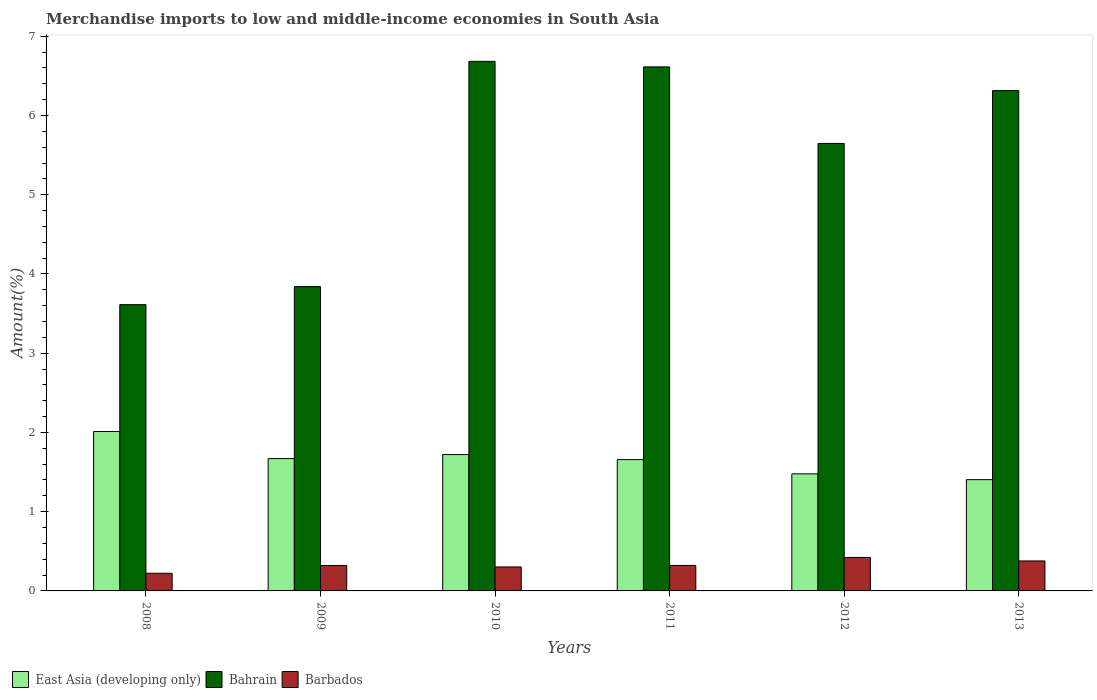How many groups of bars are there?
Your answer should be very brief. 6. Are the number of bars per tick equal to the number of legend labels?
Ensure brevity in your answer.  Yes. Are the number of bars on each tick of the X-axis equal?
Give a very brief answer. Yes. What is the label of the 1st group of bars from the left?
Ensure brevity in your answer.  2008. What is the percentage of amount earned from merchandise imports in East Asia (developing only) in 2012?
Give a very brief answer. 1.48. Across all years, what is the maximum percentage of amount earned from merchandise imports in Bahrain?
Give a very brief answer. 6.68. Across all years, what is the minimum percentage of amount earned from merchandise imports in Barbados?
Ensure brevity in your answer.  0.22. What is the total percentage of amount earned from merchandise imports in East Asia (developing only) in the graph?
Your answer should be compact. 9.94. What is the difference between the percentage of amount earned from merchandise imports in Barbados in 2008 and that in 2011?
Your answer should be compact. -0.1. What is the difference between the percentage of amount earned from merchandise imports in East Asia (developing only) in 2011 and the percentage of amount earned from merchandise imports in Bahrain in 2013?
Offer a terse response. -4.66. What is the average percentage of amount earned from merchandise imports in Bahrain per year?
Your answer should be compact. 5.45. In the year 2012, what is the difference between the percentage of amount earned from merchandise imports in Bahrain and percentage of amount earned from merchandise imports in East Asia (developing only)?
Keep it short and to the point. 4.17. In how many years, is the percentage of amount earned from merchandise imports in Barbados greater than 2.2 %?
Offer a terse response. 0. What is the ratio of the percentage of amount earned from merchandise imports in Bahrain in 2010 to that in 2012?
Provide a succinct answer. 1.18. Is the difference between the percentage of amount earned from merchandise imports in Bahrain in 2010 and 2011 greater than the difference between the percentage of amount earned from merchandise imports in East Asia (developing only) in 2010 and 2011?
Offer a very short reply. Yes. What is the difference between the highest and the second highest percentage of amount earned from merchandise imports in Barbados?
Your answer should be very brief. 0.04. What is the difference between the highest and the lowest percentage of amount earned from merchandise imports in Barbados?
Offer a very short reply. 0.2. What does the 3rd bar from the left in 2013 represents?
Your answer should be very brief. Barbados. What does the 2nd bar from the right in 2009 represents?
Offer a very short reply. Bahrain. Are all the bars in the graph horizontal?
Your response must be concise. No. Are the values on the major ticks of Y-axis written in scientific E-notation?
Ensure brevity in your answer.  No. Where does the legend appear in the graph?
Provide a succinct answer. Bottom left. What is the title of the graph?
Your answer should be very brief. Merchandise imports to low and middle-income economies in South Asia. What is the label or title of the Y-axis?
Make the answer very short. Amount(%). What is the Amount(%) in East Asia (developing only) in 2008?
Provide a succinct answer. 2.01. What is the Amount(%) of Bahrain in 2008?
Your response must be concise. 3.61. What is the Amount(%) of Barbados in 2008?
Keep it short and to the point. 0.22. What is the Amount(%) in East Asia (developing only) in 2009?
Give a very brief answer. 1.67. What is the Amount(%) of Bahrain in 2009?
Offer a very short reply. 3.84. What is the Amount(%) of Barbados in 2009?
Offer a very short reply. 0.32. What is the Amount(%) in East Asia (developing only) in 2010?
Offer a very short reply. 1.72. What is the Amount(%) of Bahrain in 2010?
Make the answer very short. 6.68. What is the Amount(%) of Barbados in 2010?
Ensure brevity in your answer.  0.3. What is the Amount(%) in East Asia (developing only) in 2011?
Your answer should be compact. 1.66. What is the Amount(%) in Bahrain in 2011?
Your answer should be very brief. 6.61. What is the Amount(%) in Barbados in 2011?
Keep it short and to the point. 0.32. What is the Amount(%) in East Asia (developing only) in 2012?
Give a very brief answer. 1.48. What is the Amount(%) of Bahrain in 2012?
Offer a very short reply. 5.65. What is the Amount(%) in Barbados in 2012?
Keep it short and to the point. 0.42. What is the Amount(%) in East Asia (developing only) in 2013?
Ensure brevity in your answer.  1.4. What is the Amount(%) of Bahrain in 2013?
Your response must be concise. 6.31. What is the Amount(%) in Barbados in 2013?
Offer a terse response. 0.38. Across all years, what is the maximum Amount(%) of East Asia (developing only)?
Make the answer very short. 2.01. Across all years, what is the maximum Amount(%) of Bahrain?
Provide a succinct answer. 6.68. Across all years, what is the maximum Amount(%) of Barbados?
Your response must be concise. 0.42. Across all years, what is the minimum Amount(%) of East Asia (developing only)?
Provide a short and direct response. 1.4. Across all years, what is the minimum Amount(%) of Bahrain?
Make the answer very short. 3.61. Across all years, what is the minimum Amount(%) of Barbados?
Offer a terse response. 0.22. What is the total Amount(%) of East Asia (developing only) in the graph?
Your response must be concise. 9.94. What is the total Amount(%) in Bahrain in the graph?
Provide a short and direct response. 32.71. What is the total Amount(%) of Barbados in the graph?
Make the answer very short. 1.97. What is the difference between the Amount(%) in East Asia (developing only) in 2008 and that in 2009?
Your response must be concise. 0.34. What is the difference between the Amount(%) of Bahrain in 2008 and that in 2009?
Provide a succinct answer. -0.23. What is the difference between the Amount(%) in Barbados in 2008 and that in 2009?
Make the answer very short. -0.1. What is the difference between the Amount(%) in East Asia (developing only) in 2008 and that in 2010?
Provide a short and direct response. 0.29. What is the difference between the Amount(%) in Bahrain in 2008 and that in 2010?
Offer a very short reply. -3.07. What is the difference between the Amount(%) of Barbados in 2008 and that in 2010?
Make the answer very short. -0.08. What is the difference between the Amount(%) in East Asia (developing only) in 2008 and that in 2011?
Your answer should be very brief. 0.35. What is the difference between the Amount(%) in Bahrain in 2008 and that in 2011?
Offer a terse response. -3. What is the difference between the Amount(%) in Barbados in 2008 and that in 2011?
Give a very brief answer. -0.1. What is the difference between the Amount(%) in East Asia (developing only) in 2008 and that in 2012?
Give a very brief answer. 0.53. What is the difference between the Amount(%) of Bahrain in 2008 and that in 2012?
Your answer should be very brief. -2.03. What is the difference between the Amount(%) in Barbados in 2008 and that in 2012?
Offer a terse response. -0.2. What is the difference between the Amount(%) of East Asia (developing only) in 2008 and that in 2013?
Make the answer very short. 0.61. What is the difference between the Amount(%) in Bahrain in 2008 and that in 2013?
Your response must be concise. -2.7. What is the difference between the Amount(%) in Barbados in 2008 and that in 2013?
Offer a terse response. -0.16. What is the difference between the Amount(%) in East Asia (developing only) in 2009 and that in 2010?
Provide a succinct answer. -0.05. What is the difference between the Amount(%) in Bahrain in 2009 and that in 2010?
Your response must be concise. -2.84. What is the difference between the Amount(%) of Barbados in 2009 and that in 2010?
Ensure brevity in your answer.  0.02. What is the difference between the Amount(%) of East Asia (developing only) in 2009 and that in 2011?
Make the answer very short. 0.01. What is the difference between the Amount(%) in Bahrain in 2009 and that in 2011?
Give a very brief answer. -2.77. What is the difference between the Amount(%) of Barbados in 2009 and that in 2011?
Give a very brief answer. -0. What is the difference between the Amount(%) of East Asia (developing only) in 2009 and that in 2012?
Make the answer very short. 0.19. What is the difference between the Amount(%) in Bahrain in 2009 and that in 2012?
Give a very brief answer. -1.81. What is the difference between the Amount(%) of Barbados in 2009 and that in 2012?
Provide a succinct answer. -0.1. What is the difference between the Amount(%) of East Asia (developing only) in 2009 and that in 2013?
Give a very brief answer. 0.27. What is the difference between the Amount(%) of Bahrain in 2009 and that in 2013?
Provide a short and direct response. -2.47. What is the difference between the Amount(%) in Barbados in 2009 and that in 2013?
Your response must be concise. -0.06. What is the difference between the Amount(%) in East Asia (developing only) in 2010 and that in 2011?
Ensure brevity in your answer.  0.06. What is the difference between the Amount(%) of Bahrain in 2010 and that in 2011?
Your answer should be compact. 0.07. What is the difference between the Amount(%) in Barbados in 2010 and that in 2011?
Your answer should be very brief. -0.02. What is the difference between the Amount(%) in East Asia (developing only) in 2010 and that in 2012?
Offer a very short reply. 0.24. What is the difference between the Amount(%) in Bahrain in 2010 and that in 2012?
Your answer should be very brief. 1.04. What is the difference between the Amount(%) in Barbados in 2010 and that in 2012?
Offer a terse response. -0.12. What is the difference between the Amount(%) of East Asia (developing only) in 2010 and that in 2013?
Ensure brevity in your answer.  0.32. What is the difference between the Amount(%) of Bahrain in 2010 and that in 2013?
Provide a short and direct response. 0.37. What is the difference between the Amount(%) in Barbados in 2010 and that in 2013?
Offer a very short reply. -0.08. What is the difference between the Amount(%) in East Asia (developing only) in 2011 and that in 2012?
Offer a very short reply. 0.18. What is the difference between the Amount(%) of Bahrain in 2011 and that in 2012?
Your answer should be compact. 0.97. What is the difference between the Amount(%) of East Asia (developing only) in 2011 and that in 2013?
Provide a short and direct response. 0.25. What is the difference between the Amount(%) of Bahrain in 2011 and that in 2013?
Your answer should be compact. 0.3. What is the difference between the Amount(%) in Barbados in 2011 and that in 2013?
Provide a succinct answer. -0.06. What is the difference between the Amount(%) of East Asia (developing only) in 2012 and that in 2013?
Offer a terse response. 0.07. What is the difference between the Amount(%) in Bahrain in 2012 and that in 2013?
Your answer should be compact. -0.67. What is the difference between the Amount(%) in Barbados in 2012 and that in 2013?
Keep it short and to the point. 0.04. What is the difference between the Amount(%) of East Asia (developing only) in 2008 and the Amount(%) of Bahrain in 2009?
Give a very brief answer. -1.83. What is the difference between the Amount(%) of East Asia (developing only) in 2008 and the Amount(%) of Barbados in 2009?
Make the answer very short. 1.69. What is the difference between the Amount(%) of Bahrain in 2008 and the Amount(%) of Barbados in 2009?
Make the answer very short. 3.29. What is the difference between the Amount(%) of East Asia (developing only) in 2008 and the Amount(%) of Bahrain in 2010?
Your answer should be compact. -4.67. What is the difference between the Amount(%) of East Asia (developing only) in 2008 and the Amount(%) of Barbados in 2010?
Ensure brevity in your answer.  1.71. What is the difference between the Amount(%) in Bahrain in 2008 and the Amount(%) in Barbados in 2010?
Provide a succinct answer. 3.31. What is the difference between the Amount(%) in East Asia (developing only) in 2008 and the Amount(%) in Bahrain in 2011?
Offer a very short reply. -4.6. What is the difference between the Amount(%) in East Asia (developing only) in 2008 and the Amount(%) in Barbados in 2011?
Your answer should be very brief. 1.69. What is the difference between the Amount(%) of Bahrain in 2008 and the Amount(%) of Barbados in 2011?
Ensure brevity in your answer.  3.29. What is the difference between the Amount(%) in East Asia (developing only) in 2008 and the Amount(%) in Bahrain in 2012?
Provide a succinct answer. -3.64. What is the difference between the Amount(%) of East Asia (developing only) in 2008 and the Amount(%) of Barbados in 2012?
Your answer should be very brief. 1.59. What is the difference between the Amount(%) in Bahrain in 2008 and the Amount(%) in Barbados in 2012?
Offer a terse response. 3.19. What is the difference between the Amount(%) of East Asia (developing only) in 2008 and the Amount(%) of Bahrain in 2013?
Your response must be concise. -4.3. What is the difference between the Amount(%) of East Asia (developing only) in 2008 and the Amount(%) of Barbados in 2013?
Provide a short and direct response. 1.63. What is the difference between the Amount(%) of Bahrain in 2008 and the Amount(%) of Barbados in 2013?
Keep it short and to the point. 3.23. What is the difference between the Amount(%) of East Asia (developing only) in 2009 and the Amount(%) of Bahrain in 2010?
Offer a terse response. -5.01. What is the difference between the Amount(%) in East Asia (developing only) in 2009 and the Amount(%) in Barbados in 2010?
Provide a short and direct response. 1.37. What is the difference between the Amount(%) of Bahrain in 2009 and the Amount(%) of Barbados in 2010?
Offer a very short reply. 3.54. What is the difference between the Amount(%) in East Asia (developing only) in 2009 and the Amount(%) in Bahrain in 2011?
Your answer should be very brief. -4.94. What is the difference between the Amount(%) in East Asia (developing only) in 2009 and the Amount(%) in Barbados in 2011?
Your response must be concise. 1.35. What is the difference between the Amount(%) in Bahrain in 2009 and the Amount(%) in Barbados in 2011?
Your response must be concise. 3.52. What is the difference between the Amount(%) of East Asia (developing only) in 2009 and the Amount(%) of Bahrain in 2012?
Keep it short and to the point. -3.98. What is the difference between the Amount(%) of East Asia (developing only) in 2009 and the Amount(%) of Barbados in 2012?
Your answer should be compact. 1.25. What is the difference between the Amount(%) of Bahrain in 2009 and the Amount(%) of Barbados in 2012?
Your answer should be very brief. 3.42. What is the difference between the Amount(%) of East Asia (developing only) in 2009 and the Amount(%) of Bahrain in 2013?
Provide a short and direct response. -4.64. What is the difference between the Amount(%) in East Asia (developing only) in 2009 and the Amount(%) in Barbados in 2013?
Ensure brevity in your answer.  1.29. What is the difference between the Amount(%) in Bahrain in 2009 and the Amount(%) in Barbados in 2013?
Your answer should be very brief. 3.46. What is the difference between the Amount(%) of East Asia (developing only) in 2010 and the Amount(%) of Bahrain in 2011?
Offer a terse response. -4.89. What is the difference between the Amount(%) in East Asia (developing only) in 2010 and the Amount(%) in Barbados in 2011?
Give a very brief answer. 1.4. What is the difference between the Amount(%) in Bahrain in 2010 and the Amount(%) in Barbados in 2011?
Make the answer very short. 6.36. What is the difference between the Amount(%) of East Asia (developing only) in 2010 and the Amount(%) of Bahrain in 2012?
Give a very brief answer. -3.93. What is the difference between the Amount(%) of East Asia (developing only) in 2010 and the Amount(%) of Barbados in 2012?
Your answer should be very brief. 1.3. What is the difference between the Amount(%) in Bahrain in 2010 and the Amount(%) in Barbados in 2012?
Your response must be concise. 6.26. What is the difference between the Amount(%) in East Asia (developing only) in 2010 and the Amount(%) in Bahrain in 2013?
Your answer should be very brief. -4.59. What is the difference between the Amount(%) in East Asia (developing only) in 2010 and the Amount(%) in Barbados in 2013?
Provide a short and direct response. 1.34. What is the difference between the Amount(%) of Bahrain in 2010 and the Amount(%) of Barbados in 2013?
Your answer should be compact. 6.3. What is the difference between the Amount(%) of East Asia (developing only) in 2011 and the Amount(%) of Bahrain in 2012?
Ensure brevity in your answer.  -3.99. What is the difference between the Amount(%) in East Asia (developing only) in 2011 and the Amount(%) in Barbados in 2012?
Keep it short and to the point. 1.24. What is the difference between the Amount(%) of Bahrain in 2011 and the Amount(%) of Barbados in 2012?
Make the answer very short. 6.19. What is the difference between the Amount(%) of East Asia (developing only) in 2011 and the Amount(%) of Bahrain in 2013?
Keep it short and to the point. -4.66. What is the difference between the Amount(%) of East Asia (developing only) in 2011 and the Amount(%) of Barbados in 2013?
Offer a terse response. 1.28. What is the difference between the Amount(%) of Bahrain in 2011 and the Amount(%) of Barbados in 2013?
Your answer should be compact. 6.23. What is the difference between the Amount(%) in East Asia (developing only) in 2012 and the Amount(%) in Bahrain in 2013?
Your answer should be very brief. -4.84. What is the difference between the Amount(%) of East Asia (developing only) in 2012 and the Amount(%) of Barbados in 2013?
Your response must be concise. 1.1. What is the difference between the Amount(%) in Bahrain in 2012 and the Amount(%) in Barbados in 2013?
Make the answer very short. 5.27. What is the average Amount(%) in East Asia (developing only) per year?
Your answer should be very brief. 1.66. What is the average Amount(%) of Bahrain per year?
Offer a very short reply. 5.45. What is the average Amount(%) of Barbados per year?
Offer a terse response. 0.33. In the year 2008, what is the difference between the Amount(%) in East Asia (developing only) and Amount(%) in Bahrain?
Make the answer very short. -1.6. In the year 2008, what is the difference between the Amount(%) in East Asia (developing only) and Amount(%) in Barbados?
Offer a terse response. 1.79. In the year 2008, what is the difference between the Amount(%) of Bahrain and Amount(%) of Barbados?
Make the answer very short. 3.39. In the year 2009, what is the difference between the Amount(%) of East Asia (developing only) and Amount(%) of Bahrain?
Ensure brevity in your answer.  -2.17. In the year 2009, what is the difference between the Amount(%) of East Asia (developing only) and Amount(%) of Barbados?
Offer a very short reply. 1.35. In the year 2009, what is the difference between the Amount(%) of Bahrain and Amount(%) of Barbados?
Your response must be concise. 3.52. In the year 2010, what is the difference between the Amount(%) in East Asia (developing only) and Amount(%) in Bahrain?
Provide a short and direct response. -4.96. In the year 2010, what is the difference between the Amount(%) in East Asia (developing only) and Amount(%) in Barbados?
Your answer should be very brief. 1.42. In the year 2010, what is the difference between the Amount(%) of Bahrain and Amount(%) of Barbados?
Offer a terse response. 6.38. In the year 2011, what is the difference between the Amount(%) of East Asia (developing only) and Amount(%) of Bahrain?
Provide a succinct answer. -4.96. In the year 2011, what is the difference between the Amount(%) of East Asia (developing only) and Amount(%) of Barbados?
Your response must be concise. 1.34. In the year 2011, what is the difference between the Amount(%) in Bahrain and Amount(%) in Barbados?
Keep it short and to the point. 6.29. In the year 2012, what is the difference between the Amount(%) in East Asia (developing only) and Amount(%) in Bahrain?
Make the answer very short. -4.17. In the year 2012, what is the difference between the Amount(%) of East Asia (developing only) and Amount(%) of Barbados?
Your response must be concise. 1.06. In the year 2012, what is the difference between the Amount(%) in Bahrain and Amount(%) in Barbados?
Provide a short and direct response. 5.23. In the year 2013, what is the difference between the Amount(%) of East Asia (developing only) and Amount(%) of Bahrain?
Make the answer very short. -4.91. In the year 2013, what is the difference between the Amount(%) of East Asia (developing only) and Amount(%) of Barbados?
Offer a very short reply. 1.03. In the year 2013, what is the difference between the Amount(%) in Bahrain and Amount(%) in Barbados?
Keep it short and to the point. 5.94. What is the ratio of the Amount(%) in East Asia (developing only) in 2008 to that in 2009?
Provide a short and direct response. 1.2. What is the ratio of the Amount(%) in Bahrain in 2008 to that in 2009?
Provide a short and direct response. 0.94. What is the ratio of the Amount(%) in Barbados in 2008 to that in 2009?
Your answer should be compact. 0.69. What is the ratio of the Amount(%) in East Asia (developing only) in 2008 to that in 2010?
Offer a very short reply. 1.17. What is the ratio of the Amount(%) in Bahrain in 2008 to that in 2010?
Your answer should be compact. 0.54. What is the ratio of the Amount(%) of Barbados in 2008 to that in 2010?
Your response must be concise. 0.74. What is the ratio of the Amount(%) in East Asia (developing only) in 2008 to that in 2011?
Ensure brevity in your answer.  1.21. What is the ratio of the Amount(%) of Bahrain in 2008 to that in 2011?
Offer a very short reply. 0.55. What is the ratio of the Amount(%) in Barbados in 2008 to that in 2011?
Your response must be concise. 0.69. What is the ratio of the Amount(%) of East Asia (developing only) in 2008 to that in 2012?
Provide a short and direct response. 1.36. What is the ratio of the Amount(%) of Bahrain in 2008 to that in 2012?
Offer a very short reply. 0.64. What is the ratio of the Amount(%) in Barbados in 2008 to that in 2012?
Your answer should be very brief. 0.53. What is the ratio of the Amount(%) in East Asia (developing only) in 2008 to that in 2013?
Make the answer very short. 1.43. What is the ratio of the Amount(%) in Bahrain in 2008 to that in 2013?
Ensure brevity in your answer.  0.57. What is the ratio of the Amount(%) in Barbados in 2008 to that in 2013?
Your response must be concise. 0.59. What is the ratio of the Amount(%) of East Asia (developing only) in 2009 to that in 2010?
Your response must be concise. 0.97. What is the ratio of the Amount(%) of Bahrain in 2009 to that in 2010?
Provide a succinct answer. 0.57. What is the ratio of the Amount(%) of Barbados in 2009 to that in 2010?
Ensure brevity in your answer.  1.06. What is the ratio of the Amount(%) in East Asia (developing only) in 2009 to that in 2011?
Give a very brief answer. 1.01. What is the ratio of the Amount(%) of Bahrain in 2009 to that in 2011?
Your answer should be compact. 0.58. What is the ratio of the Amount(%) of East Asia (developing only) in 2009 to that in 2012?
Provide a succinct answer. 1.13. What is the ratio of the Amount(%) in Bahrain in 2009 to that in 2012?
Provide a short and direct response. 0.68. What is the ratio of the Amount(%) in Barbados in 2009 to that in 2012?
Keep it short and to the point. 0.76. What is the ratio of the Amount(%) in East Asia (developing only) in 2009 to that in 2013?
Your answer should be very brief. 1.19. What is the ratio of the Amount(%) of Bahrain in 2009 to that in 2013?
Keep it short and to the point. 0.61. What is the ratio of the Amount(%) of Barbados in 2009 to that in 2013?
Your response must be concise. 0.85. What is the ratio of the Amount(%) in East Asia (developing only) in 2010 to that in 2011?
Make the answer very short. 1.04. What is the ratio of the Amount(%) in Bahrain in 2010 to that in 2011?
Provide a succinct answer. 1.01. What is the ratio of the Amount(%) in Barbados in 2010 to that in 2011?
Provide a short and direct response. 0.94. What is the ratio of the Amount(%) in East Asia (developing only) in 2010 to that in 2012?
Offer a very short reply. 1.16. What is the ratio of the Amount(%) of Bahrain in 2010 to that in 2012?
Make the answer very short. 1.18. What is the ratio of the Amount(%) of Barbados in 2010 to that in 2012?
Your answer should be very brief. 0.72. What is the ratio of the Amount(%) in East Asia (developing only) in 2010 to that in 2013?
Keep it short and to the point. 1.23. What is the ratio of the Amount(%) of Bahrain in 2010 to that in 2013?
Ensure brevity in your answer.  1.06. What is the ratio of the Amount(%) in Barbados in 2010 to that in 2013?
Make the answer very short. 0.8. What is the ratio of the Amount(%) in East Asia (developing only) in 2011 to that in 2012?
Offer a terse response. 1.12. What is the ratio of the Amount(%) in Bahrain in 2011 to that in 2012?
Offer a terse response. 1.17. What is the ratio of the Amount(%) in Barbados in 2011 to that in 2012?
Offer a very short reply. 0.76. What is the ratio of the Amount(%) in East Asia (developing only) in 2011 to that in 2013?
Your answer should be compact. 1.18. What is the ratio of the Amount(%) of Bahrain in 2011 to that in 2013?
Provide a short and direct response. 1.05. What is the ratio of the Amount(%) of Barbados in 2011 to that in 2013?
Give a very brief answer. 0.85. What is the ratio of the Amount(%) in East Asia (developing only) in 2012 to that in 2013?
Your response must be concise. 1.05. What is the ratio of the Amount(%) in Bahrain in 2012 to that in 2013?
Your answer should be very brief. 0.89. What is the ratio of the Amount(%) in Barbados in 2012 to that in 2013?
Keep it short and to the point. 1.12. What is the difference between the highest and the second highest Amount(%) of East Asia (developing only)?
Offer a terse response. 0.29. What is the difference between the highest and the second highest Amount(%) of Bahrain?
Offer a terse response. 0.07. What is the difference between the highest and the second highest Amount(%) of Barbados?
Give a very brief answer. 0.04. What is the difference between the highest and the lowest Amount(%) of East Asia (developing only)?
Your answer should be compact. 0.61. What is the difference between the highest and the lowest Amount(%) in Bahrain?
Offer a terse response. 3.07. What is the difference between the highest and the lowest Amount(%) of Barbados?
Ensure brevity in your answer.  0.2. 